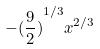Convert formula to latex. <formula><loc_0><loc_0><loc_500><loc_500>- { ( \frac { 9 } { 2 } ) } ^ { 1 / 3 } x ^ { 2 / 3 }</formula> 